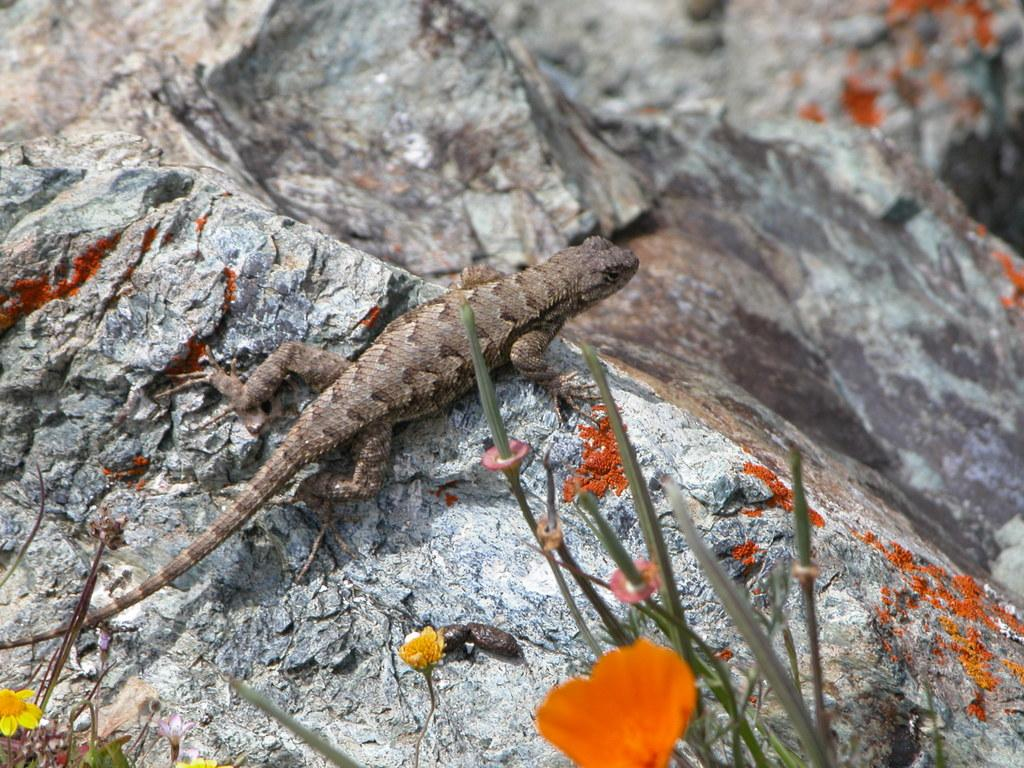What is the main subject of the image? There is an animal on a rock in the image. What other elements can be seen in the image besides the animal? There are flowers and plants in the image. What type of lettuce can be seen growing near the animal in the image? There is no lettuce present in the image; it features an animal on a rock, flowers, and plants. 